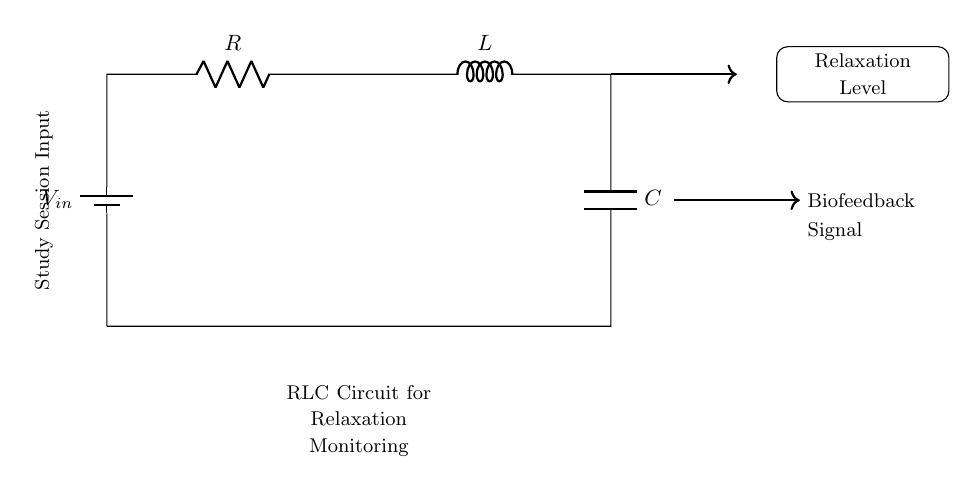What is the type of this circuit? This circuit is a series RLC circuit, which includes a resistor, an inductor, and a capacitor connected in series. The components are indicated in the diagram, and their arrangement confirms that it is a series configuration.
Answer: Series RLC What is the purpose of the biofeedback device? The biofeedback device is intended to monitor and enhance relaxation during study sessions. This can be inferred from the labeled output of the circuit, which shows the relaxation level being measured and possibly displayed.
Answer: Monitor relaxation What components are present in the circuit? The circuit includes a resistor, an inductor, and a capacitor. This is directly visible from the circuit symbols which are labeled accordingly within the diagram.
Answer: Resistor, inductor, capacitor What is the input for the circuit? The input for the circuit is labeled as V_in, which is positioned at the source location in the diagram. This indicates the voltage supply entering the circuit.
Answer: V_in How does the circuit contribute to relaxation monitoring? The circuit functions by creating a response to inputs that can be analyzed for relaxation levels. Specifically, the RLC circuit can be used to tune the response over time, which is important in biofeedback applications to determine relaxation states based on the output signal.
Answer: Analyzes response What does the arrow pointing to "Relaxation Level" signify? The arrow leading to "Relaxation Level" indicates that the output of the circuit is directly measuring or displaying this parameter, which is essential for biofeedback in relation to the user’s study session. It shows the end goal of the circuit's functionality.
Answer: Output measurement What effect does changing the values of R, L, or C have? Changing the values of the resistor, inductor, or capacitor alters the circuit's impedance and response characteristics, thus affecting the time constants and overall behavior of relaxation monitoring. This leads to variations in signal processing for relaxation feedback.
Answer: Alters circuit response 